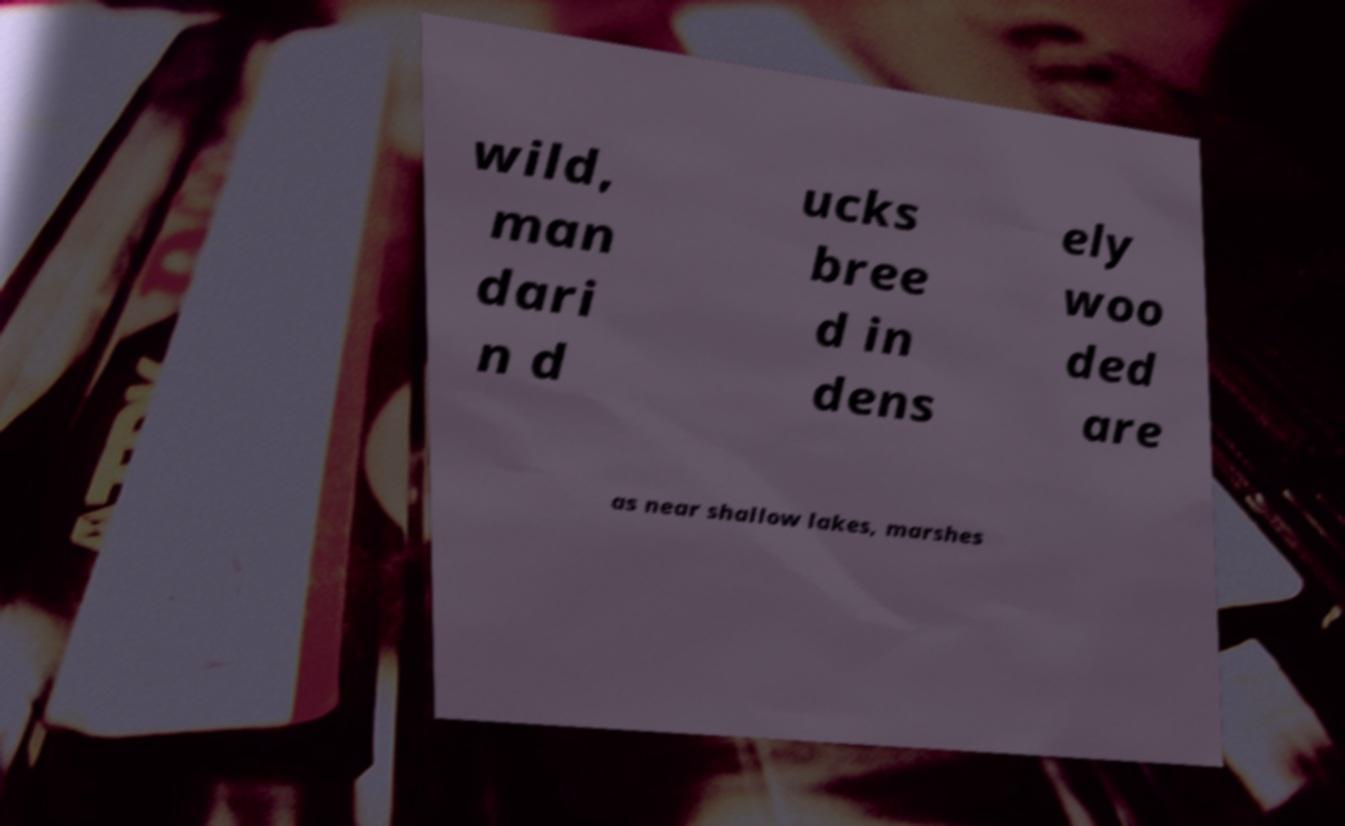Could you extract and type out the text from this image? wild, man dari n d ucks bree d in dens ely woo ded are as near shallow lakes, marshes 